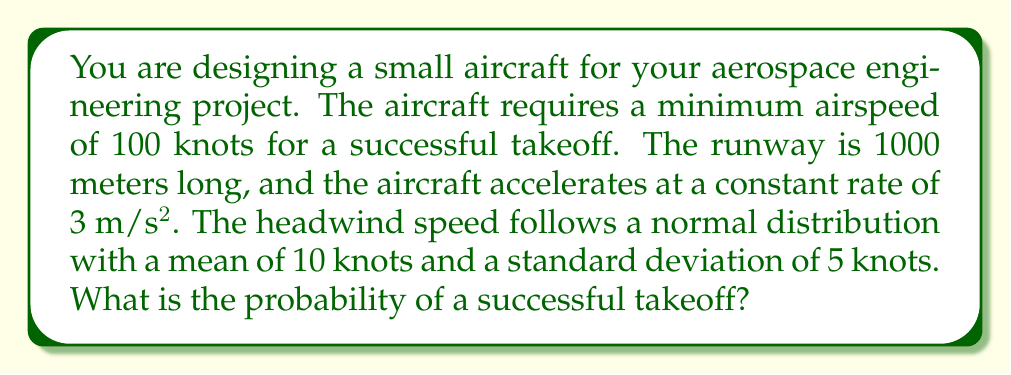Show me your answer to this math problem. Let's approach this step-by-step:

1) First, we need to calculate the ground speed required for takeoff:
   Required ground speed = Minimum airspeed - Headwind
   $$V_g = 100 - W$$
   where $W$ is the headwind speed.

2) Now, let's calculate the distance needed to reach this ground speed:
   $$d = \frac{V_g^2}{2a}$$
   where $a$ is the acceleration (3 m/s²).

3) For a successful takeoff, this distance must be less than or equal to the runway length:
   $$\frac{(100 - W)^2}{2 \cdot 3} \leq 1000$$

4) Solving for $W$:
   $$(100 - W)^2 \leq 6000$$
   $$100 - W \leq \sqrt{6000} \approx 77.46$$
   $$W \geq 22.54$$

5) So, we need a headwind of at least 22.54 knots for a successful takeoff.

6) Given that the headwind follows a normal distribution with mean $\mu = 10$ and standard deviation $\sigma = 5$, we can calculate the probability using the z-score:

   $$z = \frac{x - \mu}{\sigma} = \frac{22.54 - 10}{5} = 2.508$$

7) Using a standard normal distribution table or calculator, we can find the probability:
   $$P(W \geq 22.54) = 1 - P(Z \leq 2.508) \approx 1 - 0.9939 = 0.0061$$

Therefore, the probability of a successful takeoff is approximately 0.0061 or 0.61%.
Answer: 0.0061 